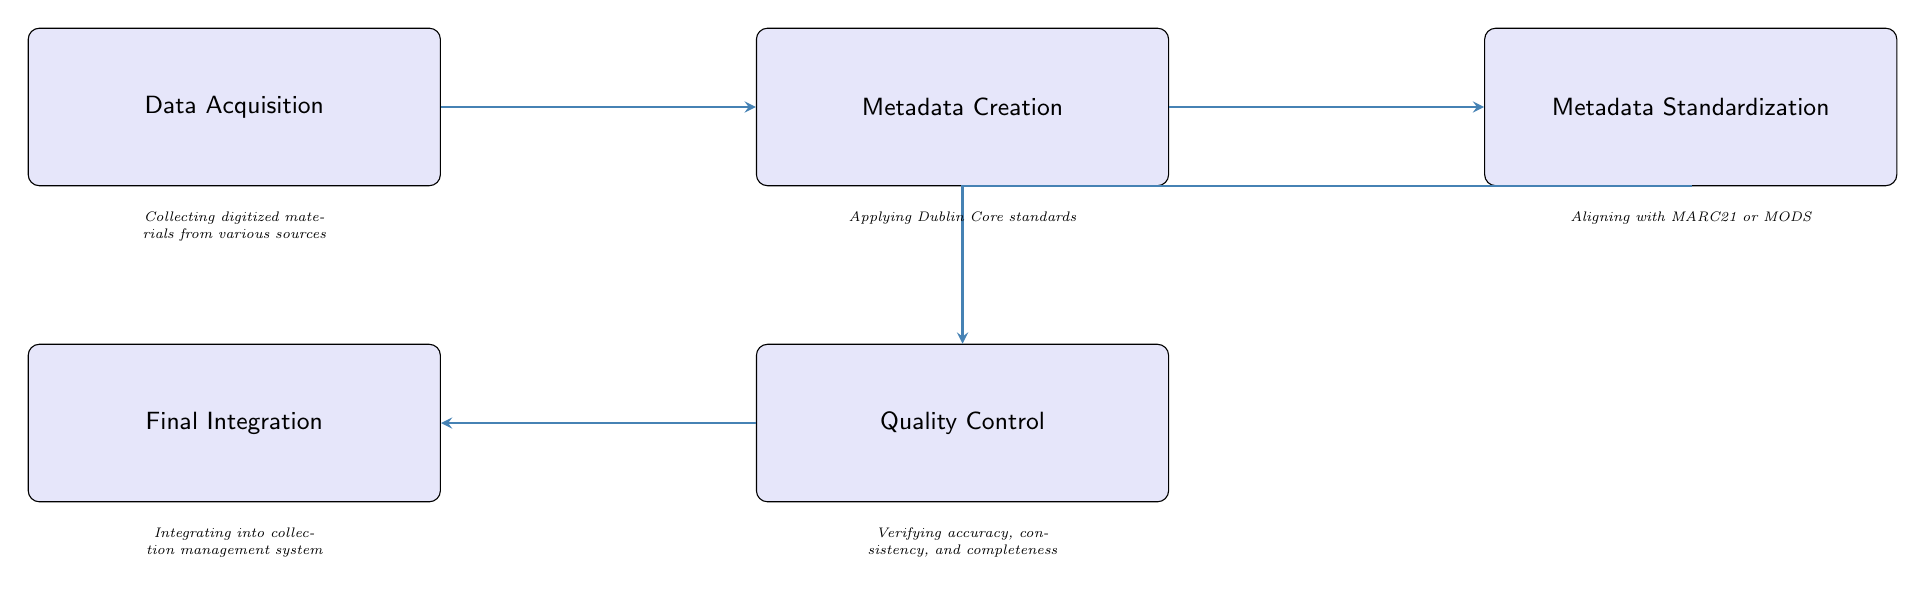What is the first node in the workflow? The diagram starts with the "Data Acquisition" node. It is the first step in the metadata curation workflow before any other processes begin.
Answer: Data Acquisition How many nodes are present in the diagram? The diagram features five distinct nodes, each representing a different step in the metadata curation workflow.
Answer: 5 Which node follows "Metadata Creation"? The node that comes after "Metadata Creation" in the workflow is "Metadata Standardization." This indicates the sequential process where creation leads to standardization.
Answer: Metadata Standardization What is the primary purpose of the "Quality Control" node? The "Quality Control" node is focused on verifying the accuracy, consistency, and completeness of the metadata, ensuring that all information adheres to the required standards before moving to the next step.
Answer: Verifying accuracy, consistency, and completeness Which nodes have an arrow pointing to "Final Integration"? The arrow pointing to "Final Integration" comes from the "Quality Control" node, indicating that after quality checks, the curated metadata is integrated into the management system.
Answer: Quality Control What metadata standards are mentioned in the workflow? The standards specified in the workflow include Dublin Core for the initial metadata and MARC21 or MODS for standardization, which helps ensure consistency across various types of metadata used.
Answer: Dublin Core, MARC21, MODS What is the relationship between "Metadata Standardization" and "Quality Control"? The relationship is that "Metadata Standardization" leads directly to "Quality Control." After metadata is standardized, it then undergoes quality checks to ensure it meets necessary requirements before final integration.
Answer: Standardization leads to Quality Control Which node does not have a successor in the workflow? "Final Integration" is the last node and does not have a subsequent step, signifying the conclusion of the workflow process.
Answer: Final Integration 